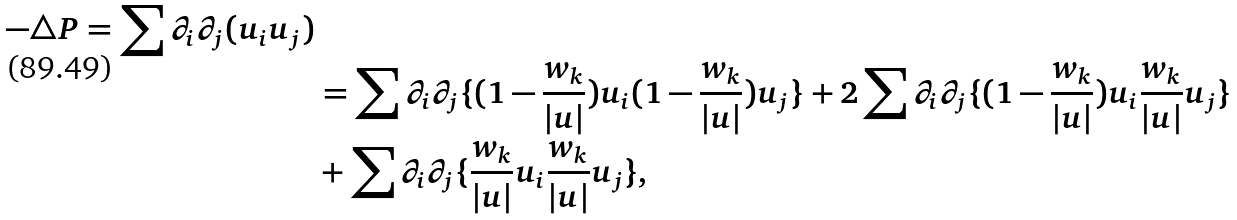<formula> <loc_0><loc_0><loc_500><loc_500>- \triangle P = \sum \partial _ { i } \partial _ { j } ( u _ { i } u _ { j } ) \\ & = \sum \partial _ { i } \partial _ { j } \{ ( 1 - \frac { w _ { k } } { | u | } ) u _ { i } ( 1 - \frac { w _ { k } } { | u | } ) u _ { j } \} + 2 \sum \partial _ { i } \partial _ { j } \{ ( 1 - \frac { w _ { k } } { | u | } ) u _ { i } \frac { w _ { k } } { | u | } u _ { j } \} \\ & + \sum \partial _ { i } \partial _ { j } \{ \frac { w _ { k } } { | u | } u _ { i } \frac { w _ { k } } { | u | } u _ { j } \} ,</formula> 